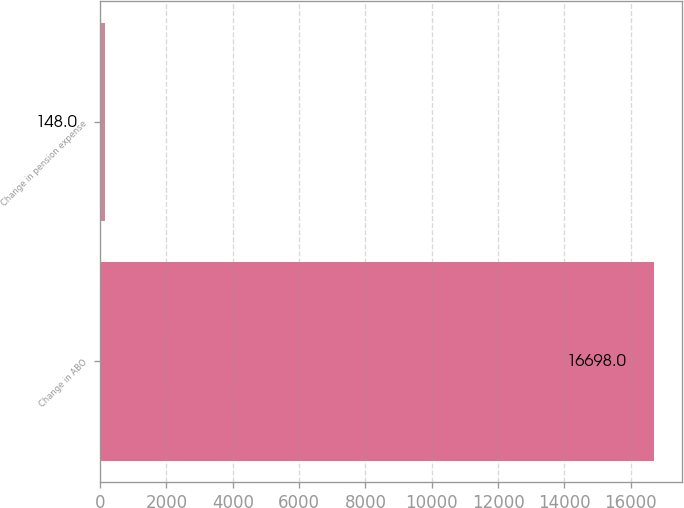<chart> <loc_0><loc_0><loc_500><loc_500><bar_chart><fcel>Change in ABO<fcel>Change in pension expense<nl><fcel>16698<fcel>148<nl></chart> 